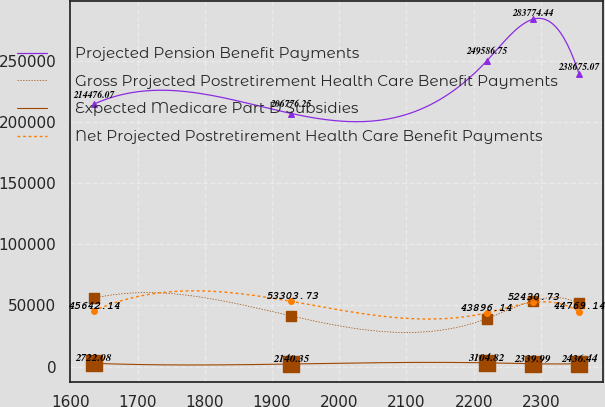Convert chart. <chart><loc_0><loc_0><loc_500><loc_500><line_chart><ecel><fcel>Projected Pension Benefit Payments<fcel>Gross Projected Postretirement Health Care Benefit Payments<fcel>Expected Medicare Part D Subsidies<fcel>Net Projected Postretirement Health Care Benefit Payments<nl><fcel>1634.94<fcel>214476<fcel>55923.1<fcel>2722.08<fcel>45642.1<nl><fcel>1928.75<fcel>206776<fcel>41394.6<fcel>2140.35<fcel>53303.7<nl><fcel>2219.24<fcel>249587<fcel>39112.7<fcel>3104.82<fcel>43896.1<nl><fcel>2288.13<fcel>283774<fcel>53735<fcel>2339.99<fcel>52430.7<nl><fcel>2357.02<fcel>238675<fcel>51623.1<fcel>2436.44<fcel>44769.1<nl></chart> 